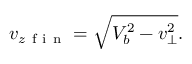<formula> <loc_0><loc_0><loc_500><loc_500>v _ { z f i n } = \sqrt { V _ { b } ^ { 2 } - v _ { \perp } ^ { 2 } } .</formula> 